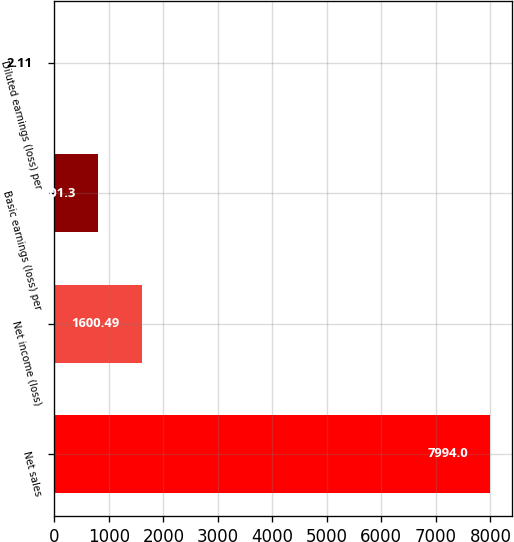Convert chart. <chart><loc_0><loc_0><loc_500><loc_500><bar_chart><fcel>Net sales<fcel>Net income (loss)<fcel>Basic earnings (loss) per<fcel>Diluted earnings (loss) per<nl><fcel>7994<fcel>1600.49<fcel>801.3<fcel>2.11<nl></chart> 